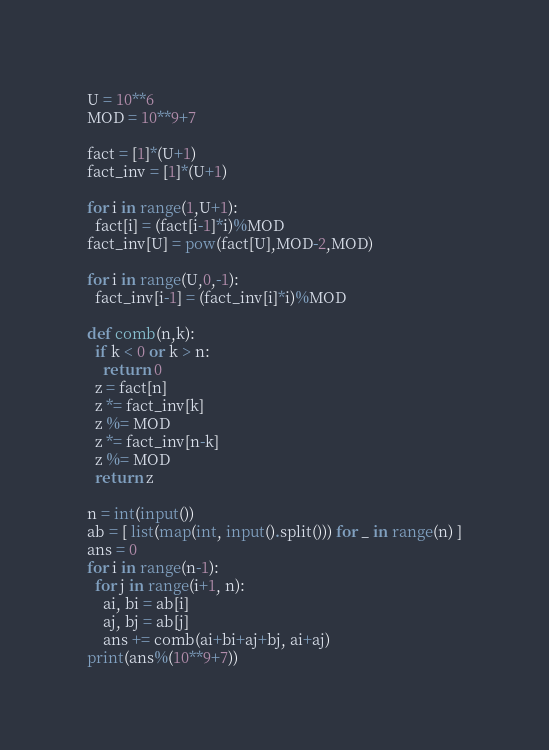<code> <loc_0><loc_0><loc_500><loc_500><_Python_>U = 10**6
MOD = 10**9+7
 
fact = [1]*(U+1)
fact_inv = [1]*(U+1)
 
for i in range(1,U+1):
  fact[i] = (fact[i-1]*i)%MOD
fact_inv[U] = pow(fact[U],MOD-2,MOD)
 
for i in range(U,0,-1):
  fact_inv[i-1] = (fact_inv[i]*i)%MOD
 
def comb(n,k):
  if k < 0 or k > n:
    return 0
  z = fact[n]
  z *= fact_inv[k]
  z %= MOD
  z *= fact_inv[n-k]
  z %= MOD
  return z

n = int(input())
ab = [ list(map(int, input().split())) for _ in range(n) ]
ans = 0
for i in range(n-1):
  for j in range(i+1, n):
    ai, bi = ab[i]
    aj, bj = ab[j]
    ans += comb(ai+bi+aj+bj, ai+aj)
print(ans%(10**9+7))</code> 